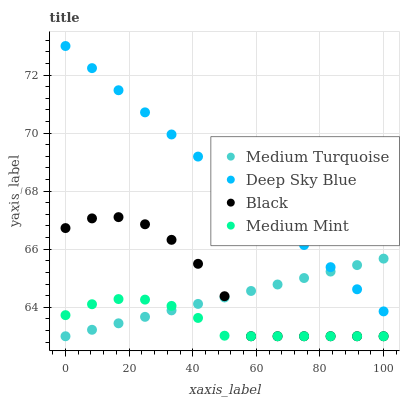Does Medium Mint have the minimum area under the curve?
Answer yes or no. Yes. Does Deep Sky Blue have the maximum area under the curve?
Answer yes or no. Yes. Does Black have the minimum area under the curve?
Answer yes or no. No. Does Black have the maximum area under the curve?
Answer yes or no. No. Is Medium Turquoise the smoothest?
Answer yes or no. Yes. Is Black the roughest?
Answer yes or no. Yes. Is Deep Sky Blue the smoothest?
Answer yes or no. No. Is Deep Sky Blue the roughest?
Answer yes or no. No. Does Medium Mint have the lowest value?
Answer yes or no. Yes. Does Deep Sky Blue have the lowest value?
Answer yes or no. No. Does Deep Sky Blue have the highest value?
Answer yes or no. Yes. Does Black have the highest value?
Answer yes or no. No. Is Black less than Deep Sky Blue?
Answer yes or no. Yes. Is Deep Sky Blue greater than Medium Mint?
Answer yes or no. Yes. Does Medium Turquoise intersect Black?
Answer yes or no. Yes. Is Medium Turquoise less than Black?
Answer yes or no. No. Is Medium Turquoise greater than Black?
Answer yes or no. No. Does Black intersect Deep Sky Blue?
Answer yes or no. No. 